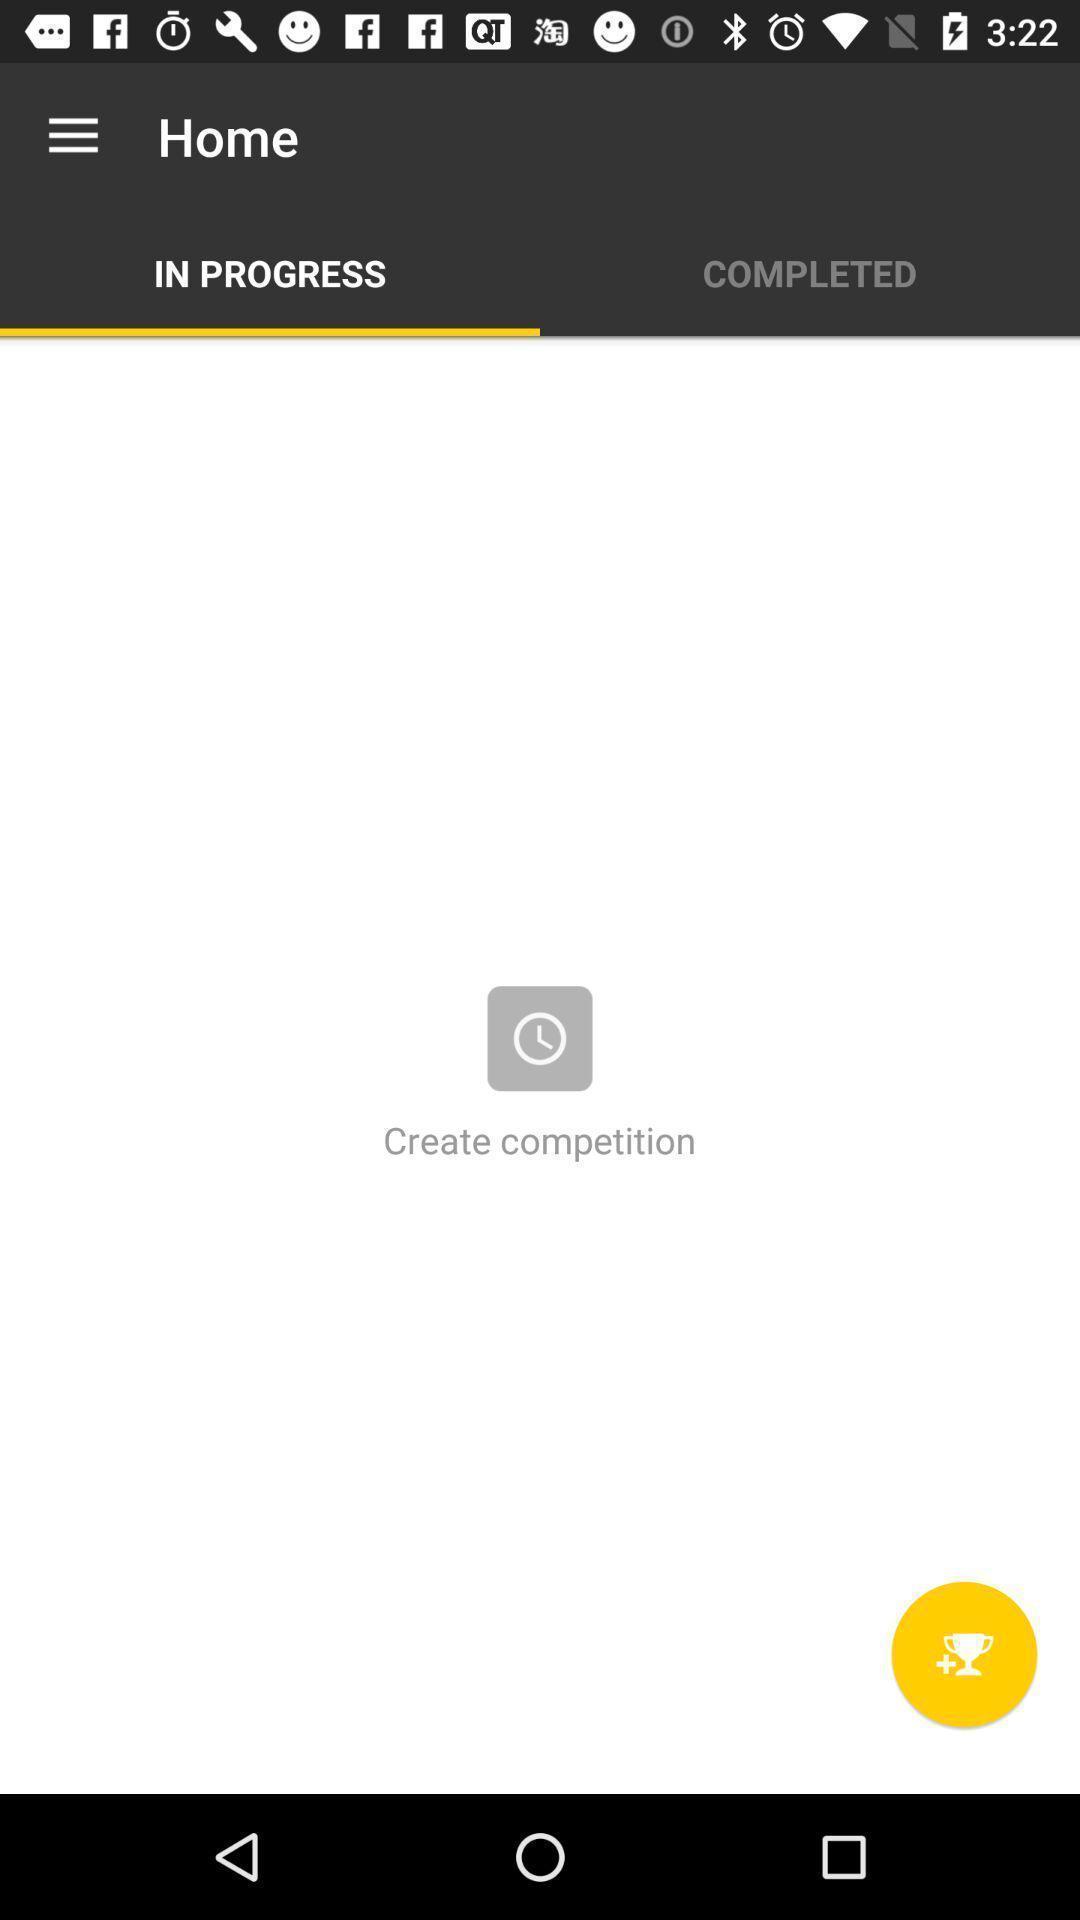Describe the content in this image. Screen displaying the progress and completed tasks. 